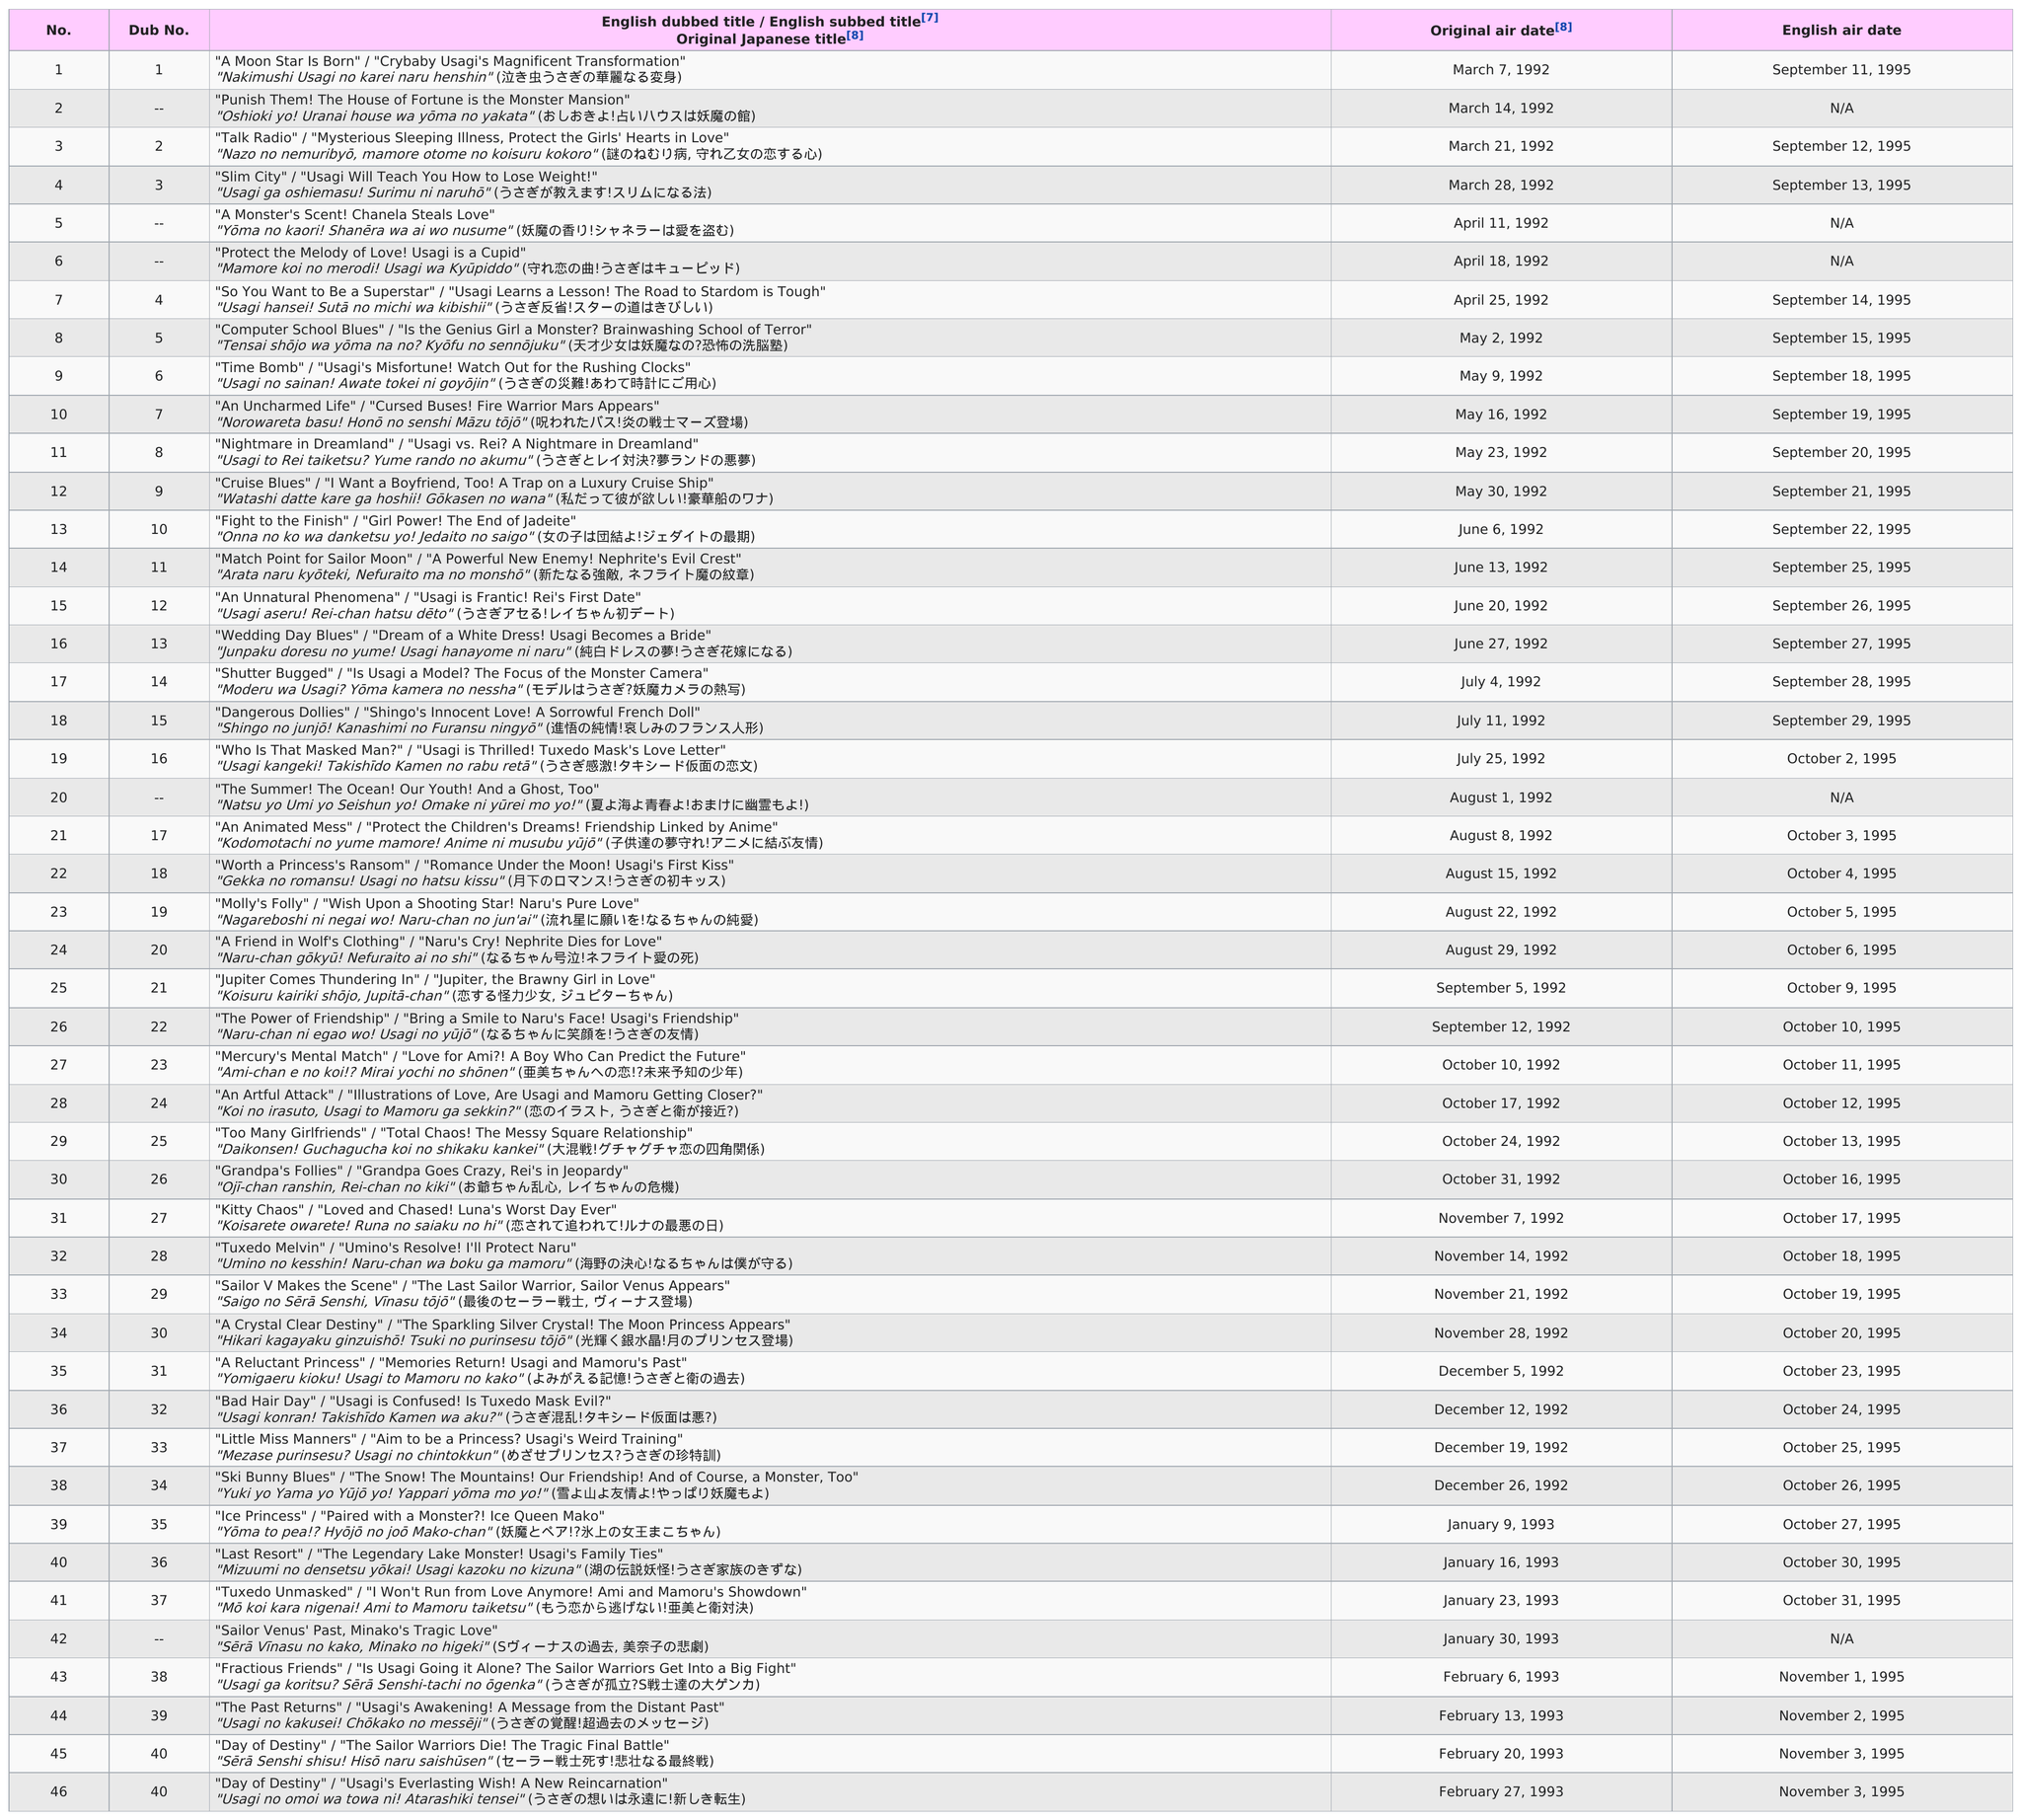List a handful of essential elements in this visual. The name of the last episode to come out in September 1995 was "Dangerous Dollies" / "Shingo's Innocent Love! A Sorrowful French Doll" / "Shingo no junjō! Kanashimi no Furansu ningyō" (進悟の純情!哀しみのフランス人形). The first sailor moon episode to have an English air date in October 1995 was "Who Is That Masked Man?" / "Usagi is Thrilled! Tuxedo Mask's Love Letter," which premiered on October 6, 1995, with the episode titled "Usagi kangeki! Takishīdo Kamen no rabu retā" (うさぎ感激!タキシード仮面の恋文). The previous episode to "Computer School Blues" is titled "So You Want to be a Superstar" / "Usagi Learns a Lesson! The Road to Stardom is Tough". There aired 22 episodes of the show in English during the month of October. Out of the total number of episodes, 41 had both an original air date and an English air date. 